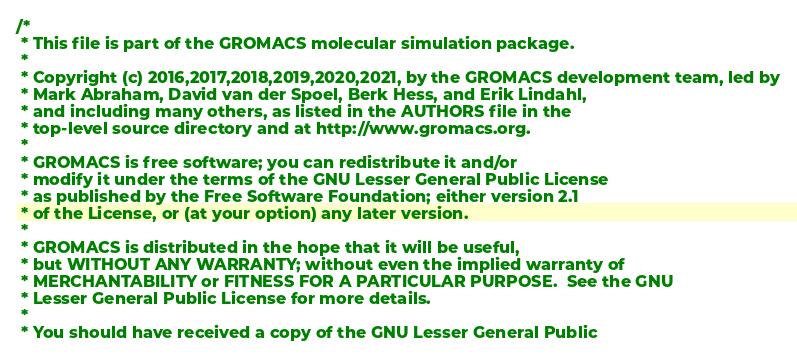<code> <loc_0><loc_0><loc_500><loc_500><_Cuda_>/*
 * This file is part of the GROMACS molecular simulation package.
 *
 * Copyright (c) 2016,2017,2018,2019,2020,2021, by the GROMACS development team, led by
 * Mark Abraham, David van der Spoel, Berk Hess, and Erik Lindahl,
 * and including many others, as listed in the AUTHORS file in the
 * top-level source directory and at http://www.gromacs.org.
 *
 * GROMACS is free software; you can redistribute it and/or
 * modify it under the terms of the GNU Lesser General Public License
 * as published by the Free Software Foundation; either version 2.1
 * of the License, or (at your option) any later version.
 *
 * GROMACS is distributed in the hope that it will be useful,
 * but WITHOUT ANY WARRANTY; without even the implied warranty of
 * MERCHANTABILITY or FITNESS FOR A PARTICULAR PURPOSE.  See the GNU
 * Lesser General Public License for more details.
 *
 * You should have received a copy of the GNU Lesser General Public</code> 